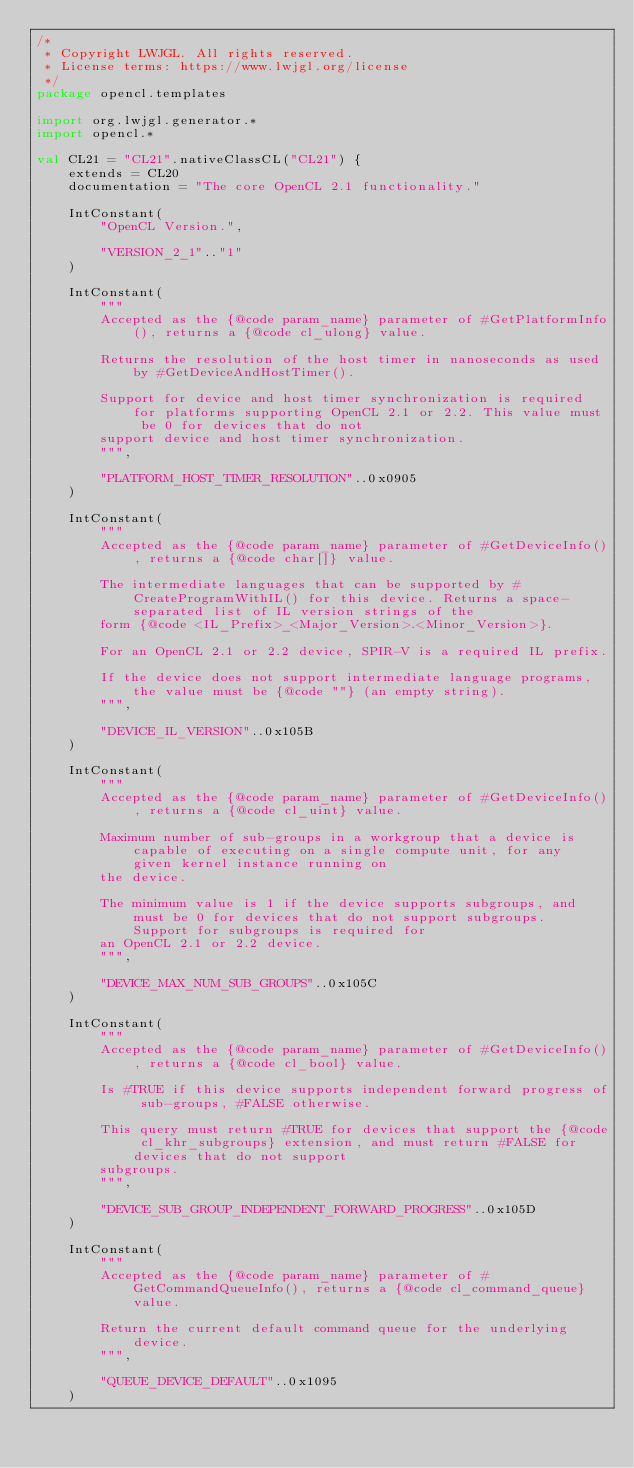Convert code to text. <code><loc_0><loc_0><loc_500><loc_500><_Kotlin_>/*
 * Copyright LWJGL. All rights reserved.
 * License terms: https://www.lwjgl.org/license
 */
package opencl.templates

import org.lwjgl.generator.*
import opencl.*

val CL21 = "CL21".nativeClassCL("CL21") {
    extends = CL20
    documentation = "The core OpenCL 2.1 functionality."

    IntConstant(
        "OpenCL Version.",

        "VERSION_2_1".."1"
    )

    IntConstant(
        """
        Accepted as the {@code param_name} parameter of #GetPlatformInfo(), returns a {@code cl_ulong} value.

        Returns the resolution of the host timer in nanoseconds as used by #GetDeviceAndHostTimer().

        Support for device and host timer synchronization is required for platforms supporting OpenCL 2.1 or 2.2. This value must be 0 for devices that do not
        support device and host timer synchronization.
        """,

        "PLATFORM_HOST_TIMER_RESOLUTION"..0x0905
    )

    IntConstant(
        """
        Accepted as the {@code param_name} parameter of #GetDeviceInfo(), returns a {@code char[]} value.

        The intermediate languages that can be supported by #CreateProgramWithIL() for this device. Returns a space-separated list of IL version strings of the
        form {@code <IL_Prefix>_<Major_Version>.<Minor_Version>}.

        For an OpenCL 2.1 or 2.2 device, SPIR-V is a required IL prefix.

        If the device does not support intermediate language programs, the value must be {@code ""} (an empty string).
        """,

        "DEVICE_IL_VERSION"..0x105B
    )

    IntConstant(
        """
        Accepted as the {@code param_name} parameter of #GetDeviceInfo(), returns a {@code cl_uint} value.

        Maximum number of sub-groups in a workgroup that a device is capable of executing on a single compute unit, for any given kernel instance running on
        the device.

        The minimum value is 1 if the device supports subgroups, and must be 0 for devices that do not support subgroups. Support for subgroups is required for
        an OpenCL 2.1 or 2.2 device.
        """,

        "DEVICE_MAX_NUM_SUB_GROUPS"..0x105C
    )

    IntConstant(
        """
        Accepted as the {@code param_name} parameter of #GetDeviceInfo(), returns a {@code cl_bool} value.

        Is #TRUE if this device supports independent forward progress of sub-groups, #FALSE otherwise.

        This query must return #TRUE for devices that support the {@code cl_khr_subgroups} extension, and must return #FALSE for devices that do not support
        subgroups.
        """,

        "DEVICE_SUB_GROUP_INDEPENDENT_FORWARD_PROGRESS"..0x105D
    )

    IntConstant(
        """
        Accepted as the {@code param_name} parameter of #GetCommandQueueInfo(), returns a {@code cl_command_queue} value.

        Return the current default command queue for the underlying device.
        """,

        "QUEUE_DEVICE_DEFAULT"..0x1095
    )
</code> 